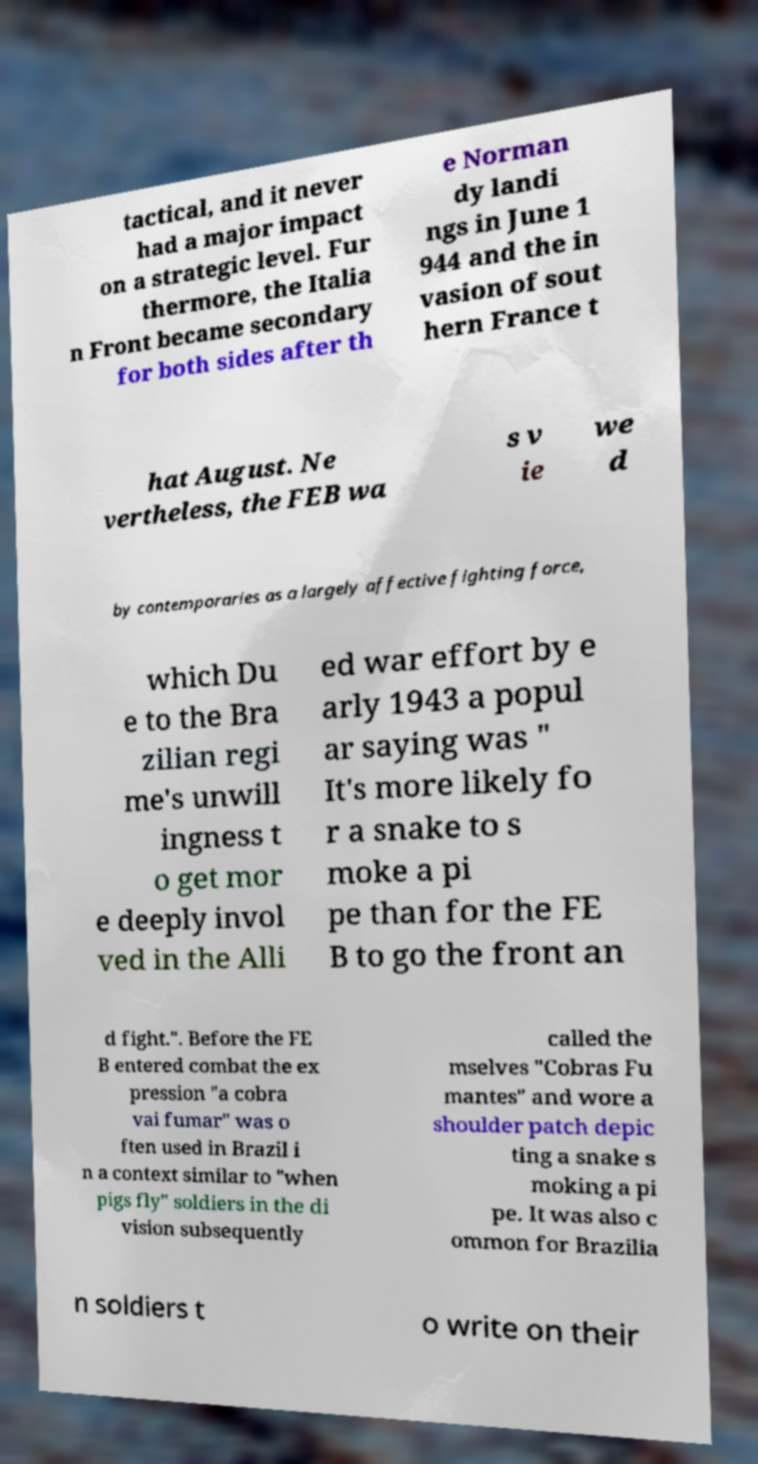I need the written content from this picture converted into text. Can you do that? tactical, and it never had a major impact on a strategic level. Fur thermore, the Italia n Front became secondary for both sides after th e Norman dy landi ngs in June 1 944 and the in vasion of sout hern France t hat August. Ne vertheless, the FEB wa s v ie we d by contemporaries as a largely affective fighting force, which Du e to the Bra zilian regi me's unwill ingness t o get mor e deeply invol ved in the Alli ed war effort by e arly 1943 a popul ar saying was " It's more likely fo r a snake to s moke a pi pe than for the FE B to go the front an d fight.". Before the FE B entered combat the ex pression "a cobra vai fumar" was o ften used in Brazil i n a context similar to "when pigs fly" soldiers in the di vision subsequently called the mselves "Cobras Fu mantes" and wore a shoulder patch depic ting a snake s moking a pi pe. It was also c ommon for Brazilia n soldiers t o write on their 